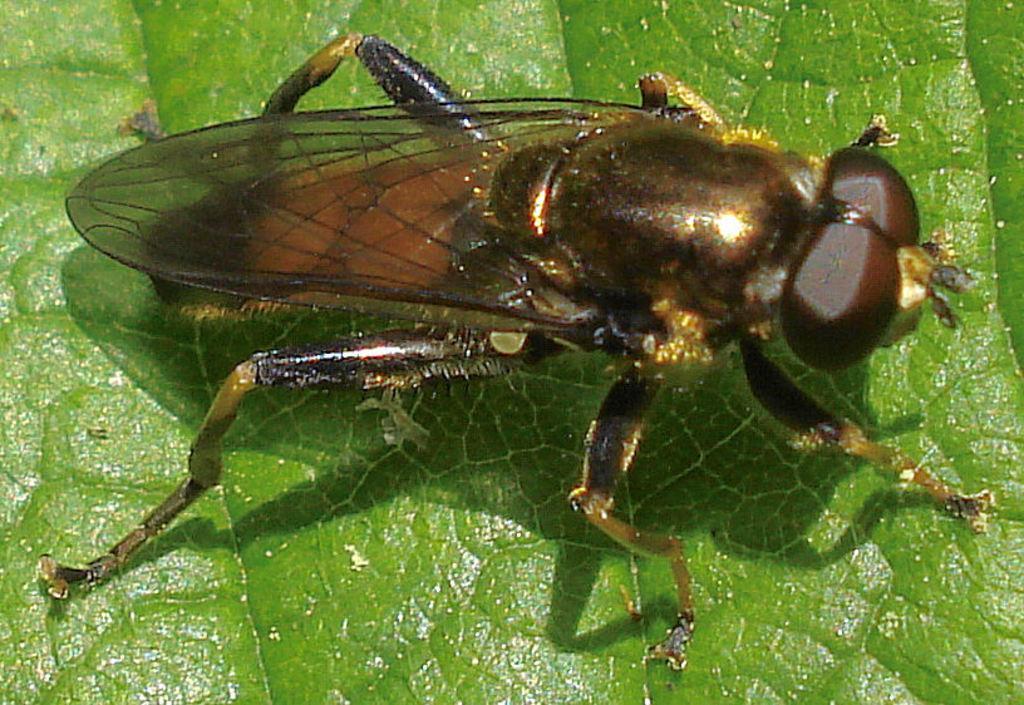Describe this image in one or two sentences. In this image we can see one insect on the green leaf. 